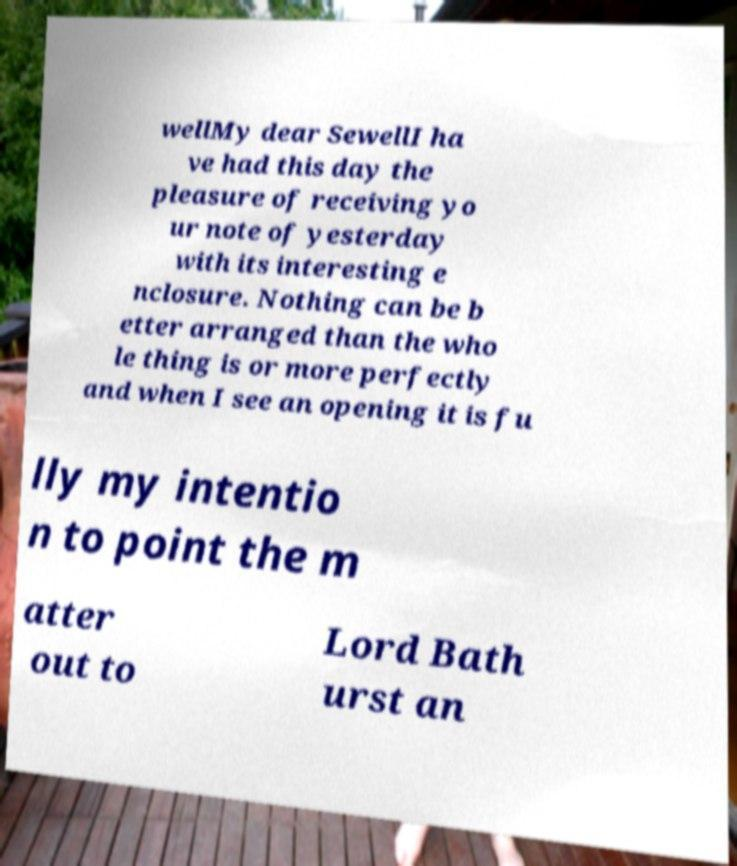Please read and relay the text visible in this image. What does it say? wellMy dear SewellI ha ve had this day the pleasure of receiving yo ur note of yesterday with its interesting e nclosure. Nothing can be b etter arranged than the who le thing is or more perfectly and when I see an opening it is fu lly my intentio n to point the m atter out to Lord Bath urst an 